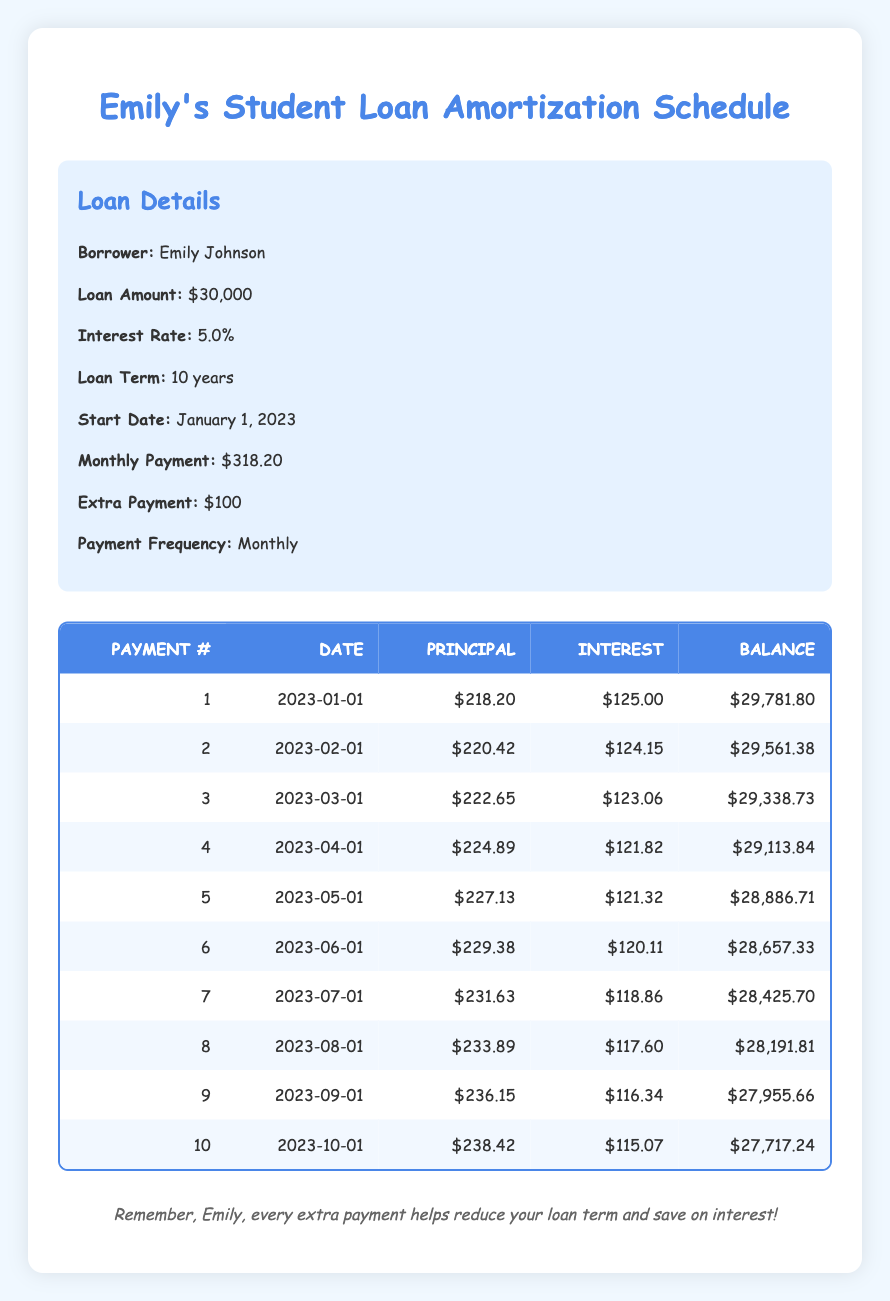What is the remaining balance after the first payment? From the table, we can see the remaining balance after the first payment (payment number 1) is $29,781.80.
Answer: 29,781.80 What is the total principal paid after the first three payments? We need to add the principal payments from the first three payments: 218.20 + 220.42 + 222.65 = 661.27.
Answer: 661.27 Did Emily's interest payment decrease after the first payment? By comparing the interest payment of the first payment ($125.00) and the second payment ($124.15), we can see that the interest payment did decrease.
Answer: Yes What is the average principal payment for the first five payments? To find the average, we add the principal payments from the first five payments: 218.20 + 220.42 + 222.65 + 224.89 + 227.13 = 1113.29, then divide by 5: 1113.29 / 5 = 222.66.
Answer: 222.66 What is the difference in remaining balance between the 10th and 1st payment? The remaining balance for the 10th payment is $27,717.24 and for the 1st payment is $29,781.80. The difference is $29,781.80 - $27,717.24 = $2,064.56.
Answer: 2,064.56 How much was the interest payment for the fifth payment? The table shows that the interest payment for the fifth payment is $121.32.
Answer: 121.32 What is the sum of the interest payments for the first four payments? Adding the interest payments of the first four payments: 125.00 + 124.15 + 123.06 + 121.82 = 494.03
Answer: 494.03 Does the principal payment increase with each payment? By looking at the principal payments listed, we see they are increasing each month: 218.20, 220.42, 222.65, 224.89, and so on. This indicates that principal payments do increase.
Answer: Yes What percentage of the monthly payment is allocated to interest in the second payment? The second payment's interest is $124.15 and the total monthly payment is $318.20. Therefore, the percentage is (124.15 / 318.20) * 100 = 39.0%.
Answer: 39.0% 